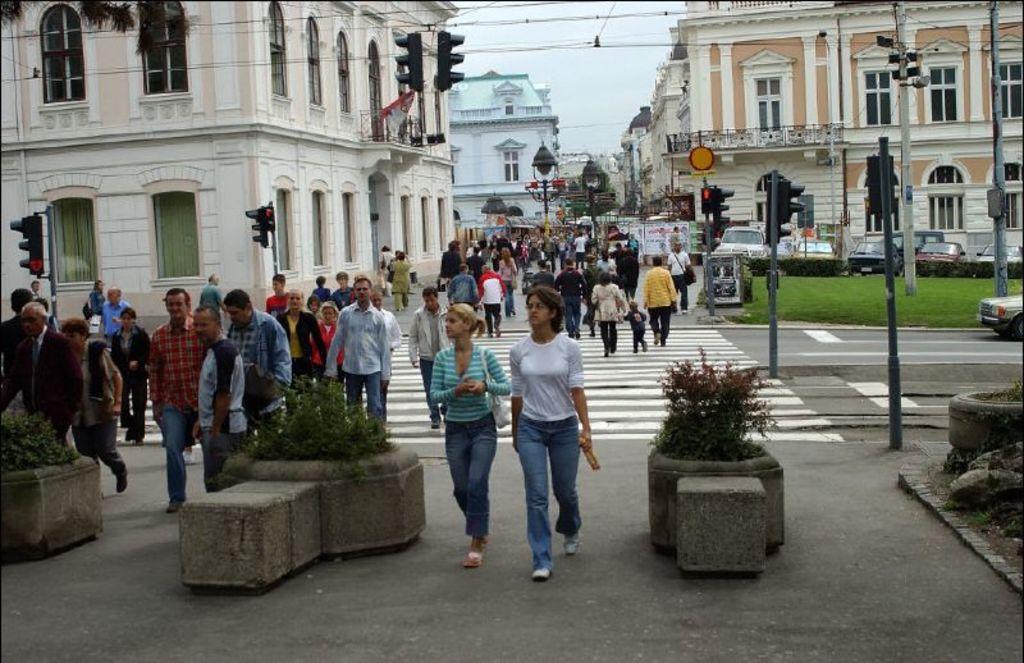Could you give a brief overview of what you see in this image? In this image there are so many people walking on the road, there are a few vehicles moving on the road and few are parked, there are trees, plants, grass, a few signal poles and utility poles. In the background there are buildings and the sky. 